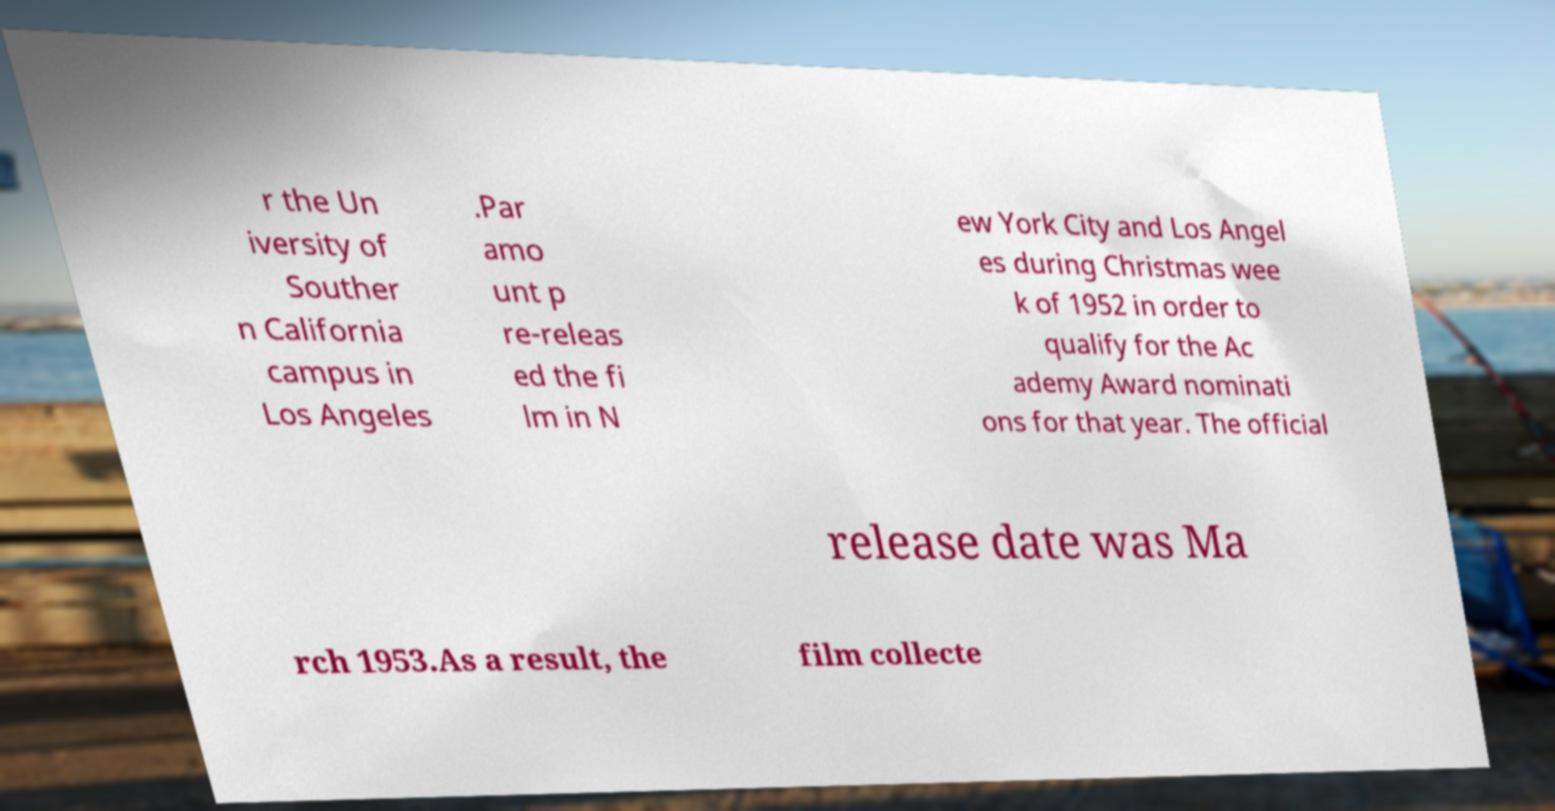Can you read and provide the text displayed in the image?This photo seems to have some interesting text. Can you extract and type it out for me? r the Un iversity of Souther n California campus in Los Angeles .Par amo unt p re-releas ed the fi lm in N ew York City and Los Angel es during Christmas wee k of 1952 in order to qualify for the Ac ademy Award nominati ons for that year. The official release date was Ma rch 1953.As a result, the film collecte 